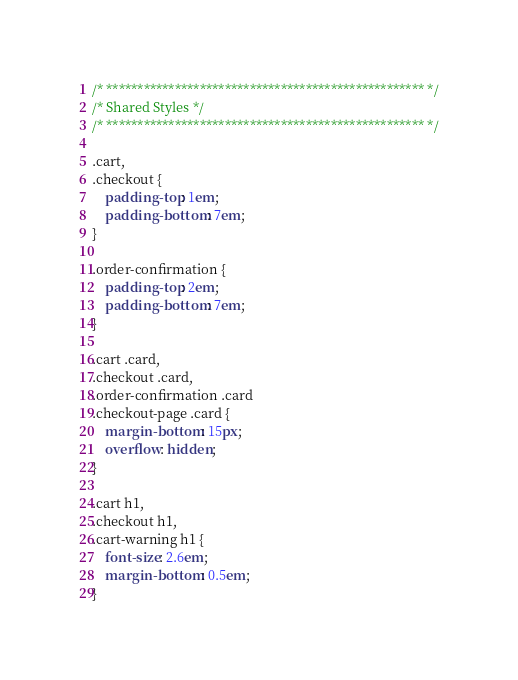Convert code to text. <code><loc_0><loc_0><loc_500><loc_500><_CSS_>/* *************************************************** */
/* Shared Styles */
/* *************************************************** */

.cart,
.checkout {
    padding-top: 1em;
    padding-bottom: 7em;
}

.order-confirmation {
    padding-top: 2em;
    padding-bottom: 7em;
}

.cart .card,
.checkout .card,
.order-confirmation .card
.checkout-page .card {
    margin-bottom: 15px;
    overflow: hidden;
}

.cart h1,
.checkout h1,
.cart-warning h1 {
    font-size: 2.6em;
    margin-bottom: 0.5em;
}
</code> 